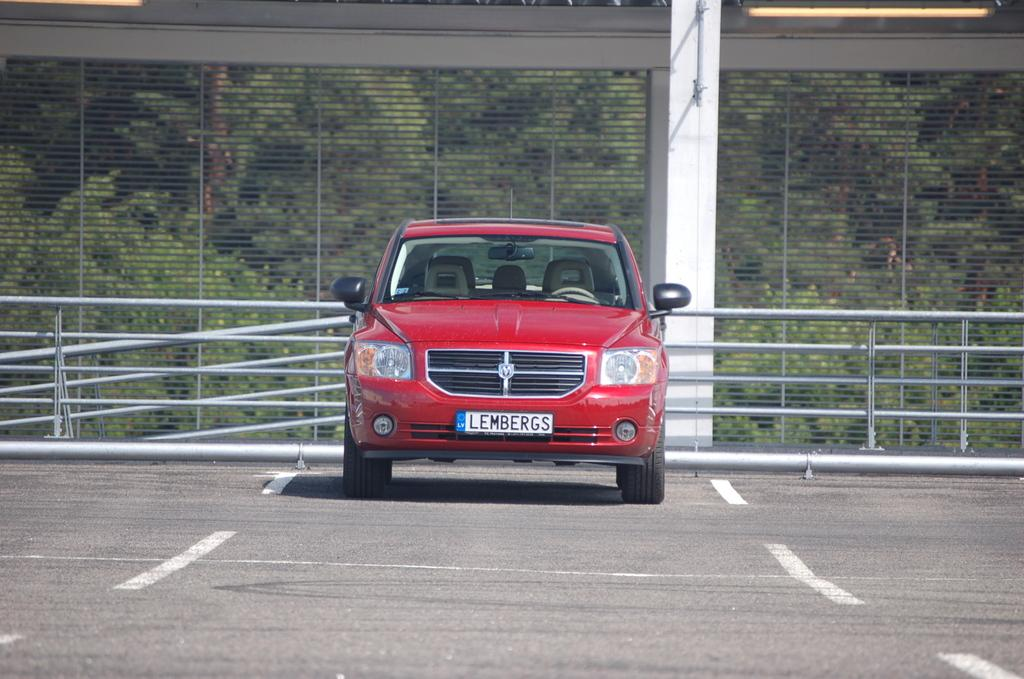What is the main subject of the image? There is a red color car in the center of the image. What separates the car from the rest of the image? There is a boundary in the center of the image. What can be seen in the background of the image? There are trees in the background of the image. How many birds are sitting on the car in the image? There are no birds present in the image; it features a red color car with a boundary and trees in the background. What type of pickle is being used to rub on the car's surface? There is no pickle or rubbing activity depicted in the image; it only shows a red color car, a boundary, and trees in the background. 